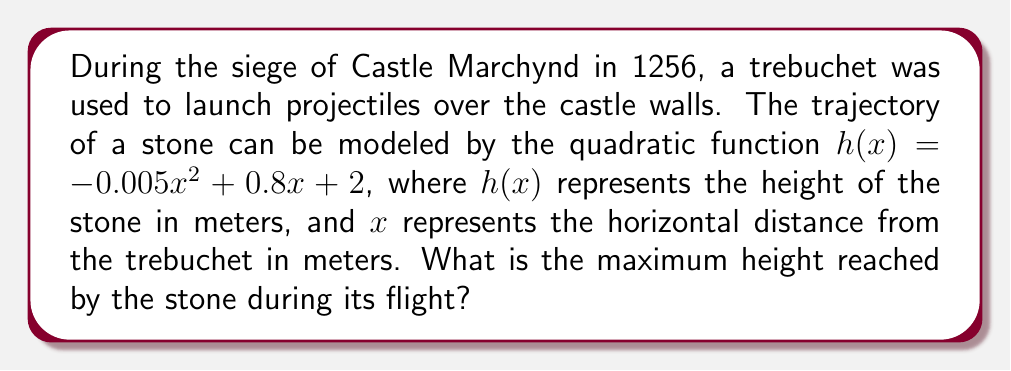Help me with this question. To find the maximum height of the stone's trajectory, we need to follow these steps:

1) The quadratic function is in the form $h(x) = ax^2 + bx + c$, where:
   $a = -0.005$
   $b = 0.8$
   $c = 2$

2) For a quadratic function, the x-coordinate of the vertex represents the point where the function reaches its maximum (if $a < 0$) or minimum (if $a > 0$).

3) The formula for the x-coordinate of the vertex is: $x = -\frac{b}{2a}$

4) Substituting our values:
   $x = -\frac{0.8}{2(-0.005)} = -\frac{0.8}{-0.01} = 80$

5) To find the maximum height, we need to calculate $h(80)$:

   $h(80) = -0.005(80)^2 + 0.8(80) + 2$
   $= -0.005(6400) + 64 + 2$
   $= -32 + 64 + 2$
   $= 34$

Therefore, the maximum height reached by the stone is 34 meters.
Answer: 34 meters 